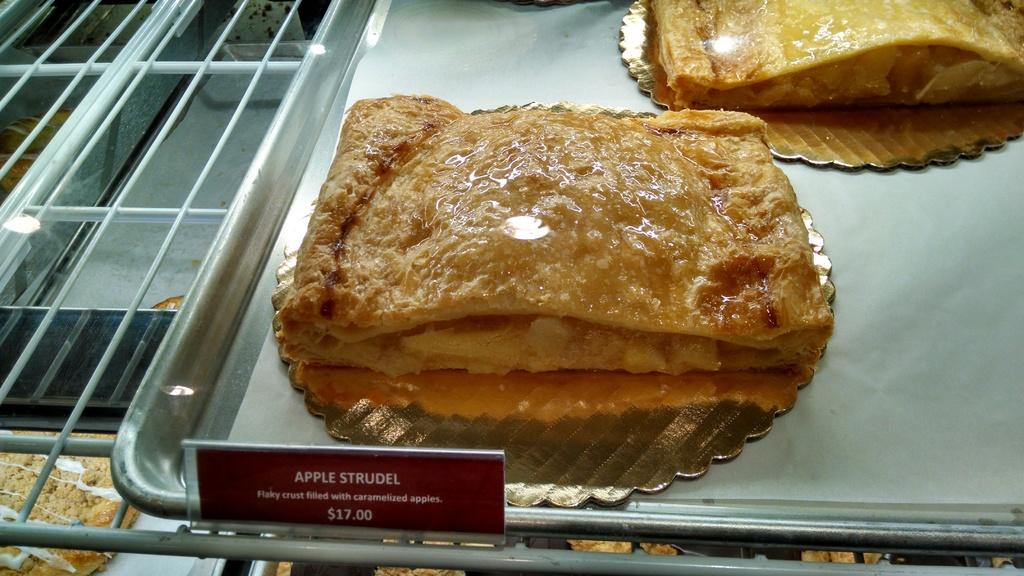What is present in the image related to food? There is food in the image, and it is placed in a tray. Can you describe any additional details about the food or tray? There is a price tag on the tray. What type of thunder can be heard in the image? There is no thunder present in the image, as it is a still image and not an audio recording. 